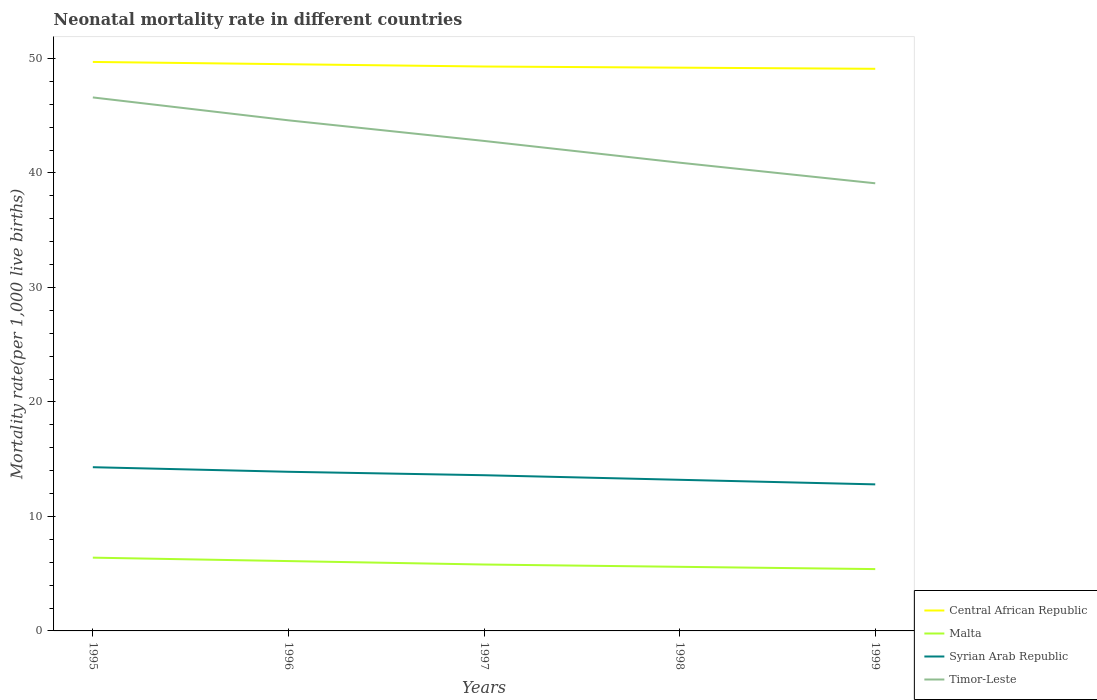How many different coloured lines are there?
Your response must be concise. 4. Across all years, what is the maximum neonatal mortality rate in Timor-Leste?
Your answer should be compact. 39.1. In which year was the neonatal mortality rate in Syrian Arab Republic maximum?
Make the answer very short. 1999. What is the total neonatal mortality rate in Malta in the graph?
Keep it short and to the point. 0.5. What is the difference between the highest and the second highest neonatal mortality rate in Syrian Arab Republic?
Offer a terse response. 1.5. What is the difference between two consecutive major ticks on the Y-axis?
Offer a terse response. 10. What is the title of the graph?
Offer a very short reply. Neonatal mortality rate in different countries. What is the label or title of the X-axis?
Ensure brevity in your answer.  Years. What is the label or title of the Y-axis?
Provide a short and direct response. Mortality rate(per 1,0 live births). What is the Mortality rate(per 1,000 live births) in Central African Republic in 1995?
Give a very brief answer. 49.7. What is the Mortality rate(per 1,000 live births) in Malta in 1995?
Your answer should be compact. 6.4. What is the Mortality rate(per 1,000 live births) of Syrian Arab Republic in 1995?
Your answer should be compact. 14.3. What is the Mortality rate(per 1,000 live births) of Timor-Leste in 1995?
Keep it short and to the point. 46.6. What is the Mortality rate(per 1,000 live births) in Central African Republic in 1996?
Offer a very short reply. 49.5. What is the Mortality rate(per 1,000 live births) of Malta in 1996?
Offer a terse response. 6.1. What is the Mortality rate(per 1,000 live births) in Timor-Leste in 1996?
Offer a very short reply. 44.6. What is the Mortality rate(per 1,000 live births) of Central African Republic in 1997?
Make the answer very short. 49.3. What is the Mortality rate(per 1,000 live births) of Malta in 1997?
Ensure brevity in your answer.  5.8. What is the Mortality rate(per 1,000 live births) of Syrian Arab Republic in 1997?
Your answer should be compact. 13.6. What is the Mortality rate(per 1,000 live births) in Timor-Leste in 1997?
Your response must be concise. 42.8. What is the Mortality rate(per 1,000 live births) of Central African Republic in 1998?
Ensure brevity in your answer.  49.2. What is the Mortality rate(per 1,000 live births) of Malta in 1998?
Provide a succinct answer. 5.6. What is the Mortality rate(per 1,000 live births) in Timor-Leste in 1998?
Ensure brevity in your answer.  40.9. What is the Mortality rate(per 1,000 live births) of Central African Republic in 1999?
Give a very brief answer. 49.1. What is the Mortality rate(per 1,000 live births) of Timor-Leste in 1999?
Offer a terse response. 39.1. Across all years, what is the maximum Mortality rate(per 1,000 live births) in Central African Republic?
Offer a terse response. 49.7. Across all years, what is the maximum Mortality rate(per 1,000 live births) of Syrian Arab Republic?
Your answer should be very brief. 14.3. Across all years, what is the maximum Mortality rate(per 1,000 live births) of Timor-Leste?
Your answer should be very brief. 46.6. Across all years, what is the minimum Mortality rate(per 1,000 live births) of Central African Republic?
Provide a short and direct response. 49.1. Across all years, what is the minimum Mortality rate(per 1,000 live births) of Timor-Leste?
Ensure brevity in your answer.  39.1. What is the total Mortality rate(per 1,000 live births) in Central African Republic in the graph?
Offer a very short reply. 246.8. What is the total Mortality rate(per 1,000 live births) in Malta in the graph?
Provide a succinct answer. 29.3. What is the total Mortality rate(per 1,000 live births) in Syrian Arab Republic in the graph?
Your response must be concise. 67.8. What is the total Mortality rate(per 1,000 live births) of Timor-Leste in the graph?
Offer a very short reply. 214. What is the difference between the Mortality rate(per 1,000 live births) in Timor-Leste in 1995 and that in 1996?
Keep it short and to the point. 2. What is the difference between the Mortality rate(per 1,000 live births) in Timor-Leste in 1995 and that in 1997?
Offer a terse response. 3.8. What is the difference between the Mortality rate(per 1,000 live births) of Syrian Arab Republic in 1995 and that in 1998?
Your response must be concise. 1.1. What is the difference between the Mortality rate(per 1,000 live births) in Timor-Leste in 1995 and that in 1998?
Keep it short and to the point. 5.7. What is the difference between the Mortality rate(per 1,000 live births) in Malta in 1995 and that in 1999?
Keep it short and to the point. 1. What is the difference between the Mortality rate(per 1,000 live births) of Syrian Arab Republic in 1995 and that in 1999?
Your answer should be compact. 1.5. What is the difference between the Mortality rate(per 1,000 live births) of Timor-Leste in 1995 and that in 1999?
Your answer should be very brief. 7.5. What is the difference between the Mortality rate(per 1,000 live births) in Malta in 1996 and that in 1997?
Ensure brevity in your answer.  0.3. What is the difference between the Mortality rate(per 1,000 live births) of Central African Republic in 1996 and that in 1998?
Your response must be concise. 0.3. What is the difference between the Mortality rate(per 1,000 live births) in Malta in 1996 and that in 1998?
Ensure brevity in your answer.  0.5. What is the difference between the Mortality rate(per 1,000 live births) in Timor-Leste in 1996 and that in 1998?
Your response must be concise. 3.7. What is the difference between the Mortality rate(per 1,000 live births) in Central African Republic in 1996 and that in 1999?
Provide a short and direct response. 0.4. What is the difference between the Mortality rate(per 1,000 live births) of Malta in 1996 and that in 1999?
Offer a terse response. 0.7. What is the difference between the Mortality rate(per 1,000 live births) in Timor-Leste in 1996 and that in 1999?
Give a very brief answer. 5.5. What is the difference between the Mortality rate(per 1,000 live births) of Timor-Leste in 1997 and that in 1998?
Your answer should be very brief. 1.9. What is the difference between the Mortality rate(per 1,000 live births) in Central African Republic in 1997 and that in 1999?
Your response must be concise. 0.2. What is the difference between the Mortality rate(per 1,000 live births) in Timor-Leste in 1997 and that in 1999?
Offer a very short reply. 3.7. What is the difference between the Mortality rate(per 1,000 live births) in Malta in 1998 and that in 1999?
Keep it short and to the point. 0.2. What is the difference between the Mortality rate(per 1,000 live births) in Syrian Arab Republic in 1998 and that in 1999?
Your answer should be compact. 0.4. What is the difference between the Mortality rate(per 1,000 live births) in Timor-Leste in 1998 and that in 1999?
Your answer should be very brief. 1.8. What is the difference between the Mortality rate(per 1,000 live births) in Central African Republic in 1995 and the Mortality rate(per 1,000 live births) in Malta in 1996?
Your response must be concise. 43.6. What is the difference between the Mortality rate(per 1,000 live births) of Central African Republic in 1995 and the Mortality rate(per 1,000 live births) of Syrian Arab Republic in 1996?
Keep it short and to the point. 35.8. What is the difference between the Mortality rate(per 1,000 live births) in Central African Republic in 1995 and the Mortality rate(per 1,000 live births) in Timor-Leste in 1996?
Ensure brevity in your answer.  5.1. What is the difference between the Mortality rate(per 1,000 live births) in Malta in 1995 and the Mortality rate(per 1,000 live births) in Timor-Leste in 1996?
Ensure brevity in your answer.  -38.2. What is the difference between the Mortality rate(per 1,000 live births) of Syrian Arab Republic in 1995 and the Mortality rate(per 1,000 live births) of Timor-Leste in 1996?
Give a very brief answer. -30.3. What is the difference between the Mortality rate(per 1,000 live births) of Central African Republic in 1995 and the Mortality rate(per 1,000 live births) of Malta in 1997?
Ensure brevity in your answer.  43.9. What is the difference between the Mortality rate(per 1,000 live births) of Central African Republic in 1995 and the Mortality rate(per 1,000 live births) of Syrian Arab Republic in 1997?
Offer a very short reply. 36.1. What is the difference between the Mortality rate(per 1,000 live births) of Malta in 1995 and the Mortality rate(per 1,000 live births) of Timor-Leste in 1997?
Provide a short and direct response. -36.4. What is the difference between the Mortality rate(per 1,000 live births) of Syrian Arab Republic in 1995 and the Mortality rate(per 1,000 live births) of Timor-Leste in 1997?
Your response must be concise. -28.5. What is the difference between the Mortality rate(per 1,000 live births) in Central African Republic in 1995 and the Mortality rate(per 1,000 live births) in Malta in 1998?
Offer a very short reply. 44.1. What is the difference between the Mortality rate(per 1,000 live births) in Central African Republic in 1995 and the Mortality rate(per 1,000 live births) in Syrian Arab Republic in 1998?
Make the answer very short. 36.5. What is the difference between the Mortality rate(per 1,000 live births) in Malta in 1995 and the Mortality rate(per 1,000 live births) in Timor-Leste in 1998?
Make the answer very short. -34.5. What is the difference between the Mortality rate(per 1,000 live births) in Syrian Arab Republic in 1995 and the Mortality rate(per 1,000 live births) in Timor-Leste in 1998?
Your response must be concise. -26.6. What is the difference between the Mortality rate(per 1,000 live births) of Central African Republic in 1995 and the Mortality rate(per 1,000 live births) of Malta in 1999?
Keep it short and to the point. 44.3. What is the difference between the Mortality rate(per 1,000 live births) in Central African Republic in 1995 and the Mortality rate(per 1,000 live births) in Syrian Arab Republic in 1999?
Your answer should be compact. 36.9. What is the difference between the Mortality rate(per 1,000 live births) in Central African Republic in 1995 and the Mortality rate(per 1,000 live births) in Timor-Leste in 1999?
Give a very brief answer. 10.6. What is the difference between the Mortality rate(per 1,000 live births) in Malta in 1995 and the Mortality rate(per 1,000 live births) in Timor-Leste in 1999?
Ensure brevity in your answer.  -32.7. What is the difference between the Mortality rate(per 1,000 live births) of Syrian Arab Republic in 1995 and the Mortality rate(per 1,000 live births) of Timor-Leste in 1999?
Offer a terse response. -24.8. What is the difference between the Mortality rate(per 1,000 live births) of Central African Republic in 1996 and the Mortality rate(per 1,000 live births) of Malta in 1997?
Keep it short and to the point. 43.7. What is the difference between the Mortality rate(per 1,000 live births) of Central African Republic in 1996 and the Mortality rate(per 1,000 live births) of Syrian Arab Republic in 1997?
Provide a short and direct response. 35.9. What is the difference between the Mortality rate(per 1,000 live births) in Central African Republic in 1996 and the Mortality rate(per 1,000 live births) in Timor-Leste in 1997?
Offer a very short reply. 6.7. What is the difference between the Mortality rate(per 1,000 live births) of Malta in 1996 and the Mortality rate(per 1,000 live births) of Timor-Leste in 1997?
Make the answer very short. -36.7. What is the difference between the Mortality rate(per 1,000 live births) of Syrian Arab Republic in 1996 and the Mortality rate(per 1,000 live births) of Timor-Leste in 1997?
Your answer should be very brief. -28.9. What is the difference between the Mortality rate(per 1,000 live births) in Central African Republic in 1996 and the Mortality rate(per 1,000 live births) in Malta in 1998?
Offer a terse response. 43.9. What is the difference between the Mortality rate(per 1,000 live births) of Central African Republic in 1996 and the Mortality rate(per 1,000 live births) of Syrian Arab Republic in 1998?
Make the answer very short. 36.3. What is the difference between the Mortality rate(per 1,000 live births) of Central African Republic in 1996 and the Mortality rate(per 1,000 live births) of Timor-Leste in 1998?
Offer a very short reply. 8.6. What is the difference between the Mortality rate(per 1,000 live births) in Malta in 1996 and the Mortality rate(per 1,000 live births) in Syrian Arab Republic in 1998?
Offer a very short reply. -7.1. What is the difference between the Mortality rate(per 1,000 live births) in Malta in 1996 and the Mortality rate(per 1,000 live births) in Timor-Leste in 1998?
Your answer should be compact. -34.8. What is the difference between the Mortality rate(per 1,000 live births) of Central African Republic in 1996 and the Mortality rate(per 1,000 live births) of Malta in 1999?
Offer a very short reply. 44.1. What is the difference between the Mortality rate(per 1,000 live births) in Central African Republic in 1996 and the Mortality rate(per 1,000 live births) in Syrian Arab Republic in 1999?
Your answer should be compact. 36.7. What is the difference between the Mortality rate(per 1,000 live births) in Malta in 1996 and the Mortality rate(per 1,000 live births) in Syrian Arab Republic in 1999?
Keep it short and to the point. -6.7. What is the difference between the Mortality rate(per 1,000 live births) of Malta in 1996 and the Mortality rate(per 1,000 live births) of Timor-Leste in 1999?
Make the answer very short. -33. What is the difference between the Mortality rate(per 1,000 live births) of Syrian Arab Republic in 1996 and the Mortality rate(per 1,000 live births) of Timor-Leste in 1999?
Your response must be concise. -25.2. What is the difference between the Mortality rate(per 1,000 live births) of Central African Republic in 1997 and the Mortality rate(per 1,000 live births) of Malta in 1998?
Provide a short and direct response. 43.7. What is the difference between the Mortality rate(per 1,000 live births) in Central African Republic in 1997 and the Mortality rate(per 1,000 live births) in Syrian Arab Republic in 1998?
Give a very brief answer. 36.1. What is the difference between the Mortality rate(per 1,000 live births) in Central African Republic in 1997 and the Mortality rate(per 1,000 live births) in Timor-Leste in 1998?
Offer a very short reply. 8.4. What is the difference between the Mortality rate(per 1,000 live births) of Malta in 1997 and the Mortality rate(per 1,000 live births) of Syrian Arab Republic in 1998?
Make the answer very short. -7.4. What is the difference between the Mortality rate(per 1,000 live births) of Malta in 1997 and the Mortality rate(per 1,000 live births) of Timor-Leste in 1998?
Give a very brief answer. -35.1. What is the difference between the Mortality rate(per 1,000 live births) of Syrian Arab Republic in 1997 and the Mortality rate(per 1,000 live births) of Timor-Leste in 1998?
Your answer should be compact. -27.3. What is the difference between the Mortality rate(per 1,000 live births) of Central African Republic in 1997 and the Mortality rate(per 1,000 live births) of Malta in 1999?
Your response must be concise. 43.9. What is the difference between the Mortality rate(per 1,000 live births) of Central African Republic in 1997 and the Mortality rate(per 1,000 live births) of Syrian Arab Republic in 1999?
Your response must be concise. 36.5. What is the difference between the Mortality rate(per 1,000 live births) in Malta in 1997 and the Mortality rate(per 1,000 live births) in Timor-Leste in 1999?
Give a very brief answer. -33.3. What is the difference between the Mortality rate(per 1,000 live births) in Syrian Arab Republic in 1997 and the Mortality rate(per 1,000 live births) in Timor-Leste in 1999?
Keep it short and to the point. -25.5. What is the difference between the Mortality rate(per 1,000 live births) in Central African Republic in 1998 and the Mortality rate(per 1,000 live births) in Malta in 1999?
Provide a succinct answer. 43.8. What is the difference between the Mortality rate(per 1,000 live births) of Central African Republic in 1998 and the Mortality rate(per 1,000 live births) of Syrian Arab Republic in 1999?
Ensure brevity in your answer.  36.4. What is the difference between the Mortality rate(per 1,000 live births) of Malta in 1998 and the Mortality rate(per 1,000 live births) of Timor-Leste in 1999?
Provide a short and direct response. -33.5. What is the difference between the Mortality rate(per 1,000 live births) in Syrian Arab Republic in 1998 and the Mortality rate(per 1,000 live births) in Timor-Leste in 1999?
Keep it short and to the point. -25.9. What is the average Mortality rate(per 1,000 live births) in Central African Republic per year?
Provide a short and direct response. 49.36. What is the average Mortality rate(per 1,000 live births) in Malta per year?
Make the answer very short. 5.86. What is the average Mortality rate(per 1,000 live births) in Syrian Arab Republic per year?
Your answer should be very brief. 13.56. What is the average Mortality rate(per 1,000 live births) in Timor-Leste per year?
Provide a short and direct response. 42.8. In the year 1995, what is the difference between the Mortality rate(per 1,000 live births) of Central African Republic and Mortality rate(per 1,000 live births) of Malta?
Your answer should be compact. 43.3. In the year 1995, what is the difference between the Mortality rate(per 1,000 live births) in Central African Republic and Mortality rate(per 1,000 live births) in Syrian Arab Republic?
Offer a terse response. 35.4. In the year 1995, what is the difference between the Mortality rate(per 1,000 live births) of Central African Republic and Mortality rate(per 1,000 live births) of Timor-Leste?
Ensure brevity in your answer.  3.1. In the year 1995, what is the difference between the Mortality rate(per 1,000 live births) of Malta and Mortality rate(per 1,000 live births) of Syrian Arab Republic?
Provide a short and direct response. -7.9. In the year 1995, what is the difference between the Mortality rate(per 1,000 live births) of Malta and Mortality rate(per 1,000 live births) of Timor-Leste?
Your answer should be very brief. -40.2. In the year 1995, what is the difference between the Mortality rate(per 1,000 live births) in Syrian Arab Republic and Mortality rate(per 1,000 live births) in Timor-Leste?
Keep it short and to the point. -32.3. In the year 1996, what is the difference between the Mortality rate(per 1,000 live births) of Central African Republic and Mortality rate(per 1,000 live births) of Malta?
Provide a succinct answer. 43.4. In the year 1996, what is the difference between the Mortality rate(per 1,000 live births) in Central African Republic and Mortality rate(per 1,000 live births) in Syrian Arab Republic?
Keep it short and to the point. 35.6. In the year 1996, what is the difference between the Mortality rate(per 1,000 live births) in Central African Republic and Mortality rate(per 1,000 live births) in Timor-Leste?
Make the answer very short. 4.9. In the year 1996, what is the difference between the Mortality rate(per 1,000 live births) in Malta and Mortality rate(per 1,000 live births) in Timor-Leste?
Provide a short and direct response. -38.5. In the year 1996, what is the difference between the Mortality rate(per 1,000 live births) in Syrian Arab Republic and Mortality rate(per 1,000 live births) in Timor-Leste?
Your response must be concise. -30.7. In the year 1997, what is the difference between the Mortality rate(per 1,000 live births) of Central African Republic and Mortality rate(per 1,000 live births) of Malta?
Your answer should be very brief. 43.5. In the year 1997, what is the difference between the Mortality rate(per 1,000 live births) in Central African Republic and Mortality rate(per 1,000 live births) in Syrian Arab Republic?
Offer a very short reply. 35.7. In the year 1997, what is the difference between the Mortality rate(per 1,000 live births) of Central African Republic and Mortality rate(per 1,000 live births) of Timor-Leste?
Your answer should be very brief. 6.5. In the year 1997, what is the difference between the Mortality rate(per 1,000 live births) of Malta and Mortality rate(per 1,000 live births) of Syrian Arab Republic?
Provide a short and direct response. -7.8. In the year 1997, what is the difference between the Mortality rate(per 1,000 live births) of Malta and Mortality rate(per 1,000 live births) of Timor-Leste?
Make the answer very short. -37. In the year 1997, what is the difference between the Mortality rate(per 1,000 live births) of Syrian Arab Republic and Mortality rate(per 1,000 live births) of Timor-Leste?
Your answer should be compact. -29.2. In the year 1998, what is the difference between the Mortality rate(per 1,000 live births) in Central African Republic and Mortality rate(per 1,000 live births) in Malta?
Make the answer very short. 43.6. In the year 1998, what is the difference between the Mortality rate(per 1,000 live births) of Central African Republic and Mortality rate(per 1,000 live births) of Syrian Arab Republic?
Offer a terse response. 36. In the year 1998, what is the difference between the Mortality rate(per 1,000 live births) in Central African Republic and Mortality rate(per 1,000 live births) in Timor-Leste?
Your response must be concise. 8.3. In the year 1998, what is the difference between the Mortality rate(per 1,000 live births) of Malta and Mortality rate(per 1,000 live births) of Timor-Leste?
Your response must be concise. -35.3. In the year 1998, what is the difference between the Mortality rate(per 1,000 live births) of Syrian Arab Republic and Mortality rate(per 1,000 live births) of Timor-Leste?
Ensure brevity in your answer.  -27.7. In the year 1999, what is the difference between the Mortality rate(per 1,000 live births) of Central African Republic and Mortality rate(per 1,000 live births) of Malta?
Provide a short and direct response. 43.7. In the year 1999, what is the difference between the Mortality rate(per 1,000 live births) in Central African Republic and Mortality rate(per 1,000 live births) in Syrian Arab Republic?
Your response must be concise. 36.3. In the year 1999, what is the difference between the Mortality rate(per 1,000 live births) in Malta and Mortality rate(per 1,000 live births) in Timor-Leste?
Your answer should be very brief. -33.7. In the year 1999, what is the difference between the Mortality rate(per 1,000 live births) of Syrian Arab Republic and Mortality rate(per 1,000 live births) of Timor-Leste?
Ensure brevity in your answer.  -26.3. What is the ratio of the Mortality rate(per 1,000 live births) in Central African Republic in 1995 to that in 1996?
Offer a very short reply. 1. What is the ratio of the Mortality rate(per 1,000 live births) in Malta in 1995 to that in 1996?
Your response must be concise. 1.05. What is the ratio of the Mortality rate(per 1,000 live births) in Syrian Arab Republic in 1995 to that in 1996?
Offer a very short reply. 1.03. What is the ratio of the Mortality rate(per 1,000 live births) of Timor-Leste in 1995 to that in 1996?
Ensure brevity in your answer.  1.04. What is the ratio of the Mortality rate(per 1,000 live births) of Central African Republic in 1995 to that in 1997?
Provide a short and direct response. 1.01. What is the ratio of the Mortality rate(per 1,000 live births) in Malta in 1995 to that in 1997?
Provide a short and direct response. 1.1. What is the ratio of the Mortality rate(per 1,000 live births) of Syrian Arab Republic in 1995 to that in 1997?
Keep it short and to the point. 1.05. What is the ratio of the Mortality rate(per 1,000 live births) in Timor-Leste in 1995 to that in 1997?
Keep it short and to the point. 1.09. What is the ratio of the Mortality rate(per 1,000 live births) in Central African Republic in 1995 to that in 1998?
Your answer should be compact. 1.01. What is the ratio of the Mortality rate(per 1,000 live births) in Syrian Arab Republic in 1995 to that in 1998?
Provide a short and direct response. 1.08. What is the ratio of the Mortality rate(per 1,000 live births) of Timor-Leste in 1995 to that in 1998?
Ensure brevity in your answer.  1.14. What is the ratio of the Mortality rate(per 1,000 live births) of Central African Republic in 1995 to that in 1999?
Offer a very short reply. 1.01. What is the ratio of the Mortality rate(per 1,000 live births) of Malta in 1995 to that in 1999?
Keep it short and to the point. 1.19. What is the ratio of the Mortality rate(per 1,000 live births) of Syrian Arab Republic in 1995 to that in 1999?
Keep it short and to the point. 1.12. What is the ratio of the Mortality rate(per 1,000 live births) of Timor-Leste in 1995 to that in 1999?
Keep it short and to the point. 1.19. What is the ratio of the Mortality rate(per 1,000 live births) in Central African Republic in 1996 to that in 1997?
Your response must be concise. 1. What is the ratio of the Mortality rate(per 1,000 live births) in Malta in 1996 to that in 1997?
Give a very brief answer. 1.05. What is the ratio of the Mortality rate(per 1,000 live births) in Syrian Arab Republic in 1996 to that in 1997?
Give a very brief answer. 1.02. What is the ratio of the Mortality rate(per 1,000 live births) of Timor-Leste in 1996 to that in 1997?
Keep it short and to the point. 1.04. What is the ratio of the Mortality rate(per 1,000 live births) of Malta in 1996 to that in 1998?
Ensure brevity in your answer.  1.09. What is the ratio of the Mortality rate(per 1,000 live births) in Syrian Arab Republic in 1996 to that in 1998?
Ensure brevity in your answer.  1.05. What is the ratio of the Mortality rate(per 1,000 live births) in Timor-Leste in 1996 to that in 1998?
Offer a very short reply. 1.09. What is the ratio of the Mortality rate(per 1,000 live births) of Central African Republic in 1996 to that in 1999?
Your response must be concise. 1.01. What is the ratio of the Mortality rate(per 1,000 live births) in Malta in 1996 to that in 1999?
Your answer should be compact. 1.13. What is the ratio of the Mortality rate(per 1,000 live births) in Syrian Arab Republic in 1996 to that in 1999?
Offer a very short reply. 1.09. What is the ratio of the Mortality rate(per 1,000 live births) of Timor-Leste in 1996 to that in 1999?
Offer a very short reply. 1.14. What is the ratio of the Mortality rate(per 1,000 live births) of Central African Republic in 1997 to that in 1998?
Your answer should be very brief. 1. What is the ratio of the Mortality rate(per 1,000 live births) in Malta in 1997 to that in 1998?
Your answer should be compact. 1.04. What is the ratio of the Mortality rate(per 1,000 live births) in Syrian Arab Republic in 1997 to that in 1998?
Ensure brevity in your answer.  1.03. What is the ratio of the Mortality rate(per 1,000 live births) of Timor-Leste in 1997 to that in 1998?
Your answer should be compact. 1.05. What is the ratio of the Mortality rate(per 1,000 live births) in Malta in 1997 to that in 1999?
Your answer should be compact. 1.07. What is the ratio of the Mortality rate(per 1,000 live births) in Timor-Leste in 1997 to that in 1999?
Give a very brief answer. 1.09. What is the ratio of the Mortality rate(per 1,000 live births) of Malta in 1998 to that in 1999?
Offer a very short reply. 1.04. What is the ratio of the Mortality rate(per 1,000 live births) in Syrian Arab Republic in 1998 to that in 1999?
Your answer should be very brief. 1.03. What is the ratio of the Mortality rate(per 1,000 live births) of Timor-Leste in 1998 to that in 1999?
Give a very brief answer. 1.05. What is the difference between the highest and the second highest Mortality rate(per 1,000 live births) of Central African Republic?
Offer a very short reply. 0.2. What is the difference between the highest and the second highest Mortality rate(per 1,000 live births) in Syrian Arab Republic?
Keep it short and to the point. 0.4. What is the difference between the highest and the second highest Mortality rate(per 1,000 live births) of Timor-Leste?
Offer a very short reply. 2. What is the difference between the highest and the lowest Mortality rate(per 1,000 live births) in Central African Republic?
Ensure brevity in your answer.  0.6. What is the difference between the highest and the lowest Mortality rate(per 1,000 live births) in Malta?
Offer a terse response. 1. What is the difference between the highest and the lowest Mortality rate(per 1,000 live births) in Syrian Arab Republic?
Your answer should be very brief. 1.5. 